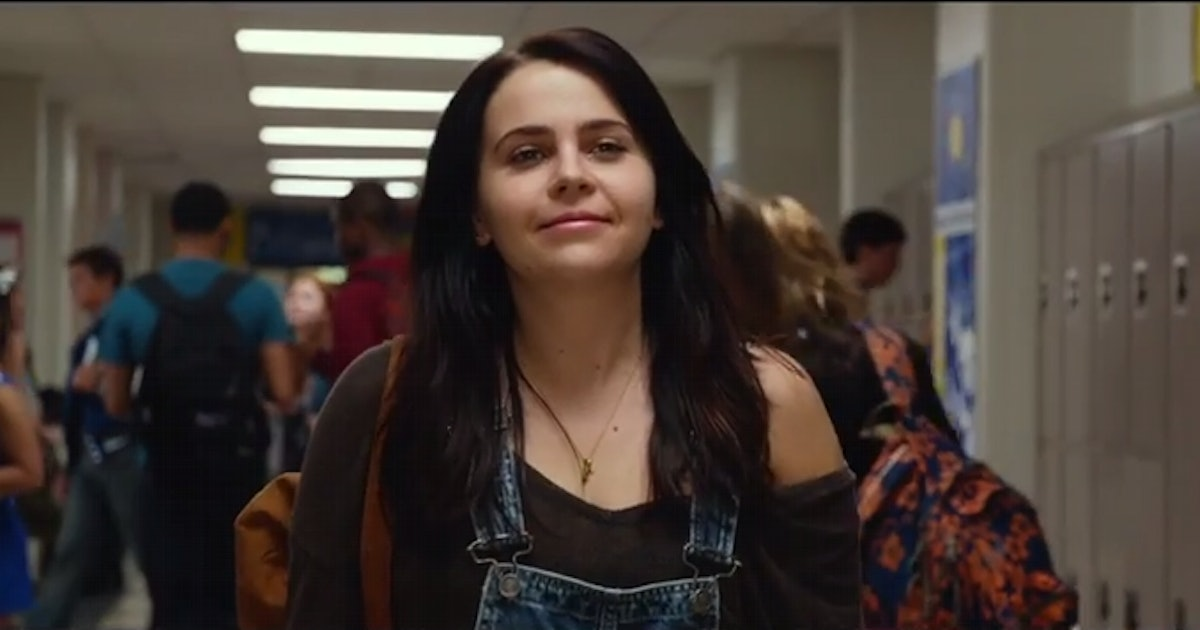What emotions does the character seem to be conveying in this scene? The character appears to be conveying a sense of confident calmness mixed with a bit of introspection. Her smile is mild and seems to reflect a comfortable familiarity with her surroundings, perhaps indicating her contentment or mild amusement at the hustle of school life around her. 